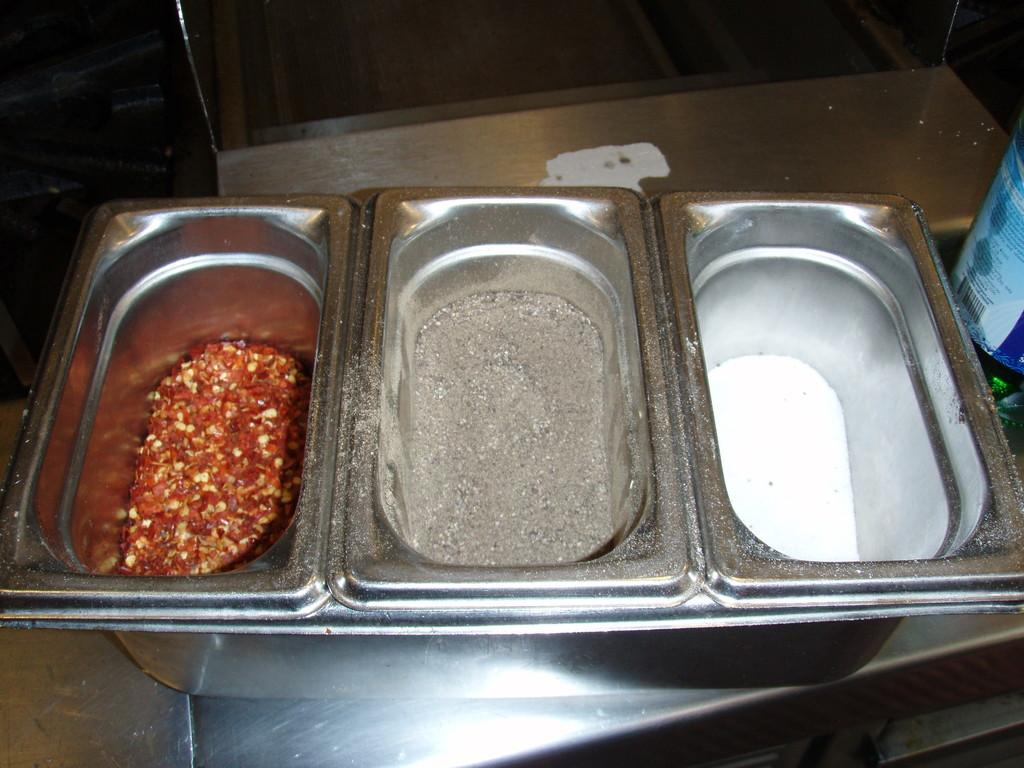What objects are on the table in the image? There are vessels on a table in the image. What do the vessels contain? The vessels contain spices, including chilli flakes, pepper powder, and salt. What else can be seen on the table in the image? There is a tin on the table in the image. What type of rice can be seen in the vessels in the image? There is no rice present in the vessels or the image; they contain spices such as chilli flakes, pepper powder, and salt. Is there a key visible in the image? There is no key present in the image. 